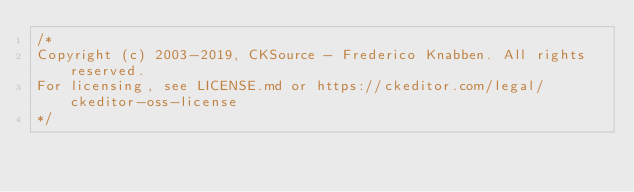Convert code to text. <code><loc_0><loc_0><loc_500><loc_500><_CSS_>/*
Copyright (c) 2003-2019, CKSource - Frederico Knabben. All rights reserved.
For licensing, see LICENSE.md or https://ckeditor.com/legal/ckeditor-oss-license
*/</code> 